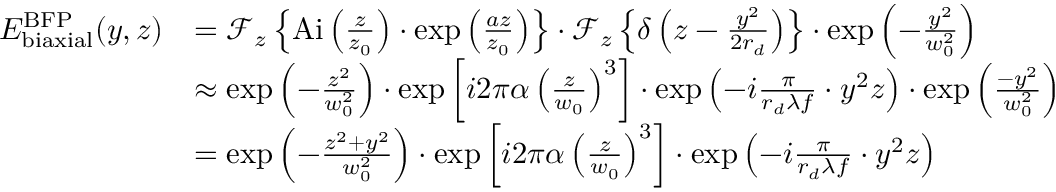Convert formula to latex. <formula><loc_0><loc_0><loc_500><loc_500>\begin{array} { r l } { E _ { b i a x i a l } ^ { B F P } ( y , z ) } & { = { \mathcal { F } } _ { z } \left \{ { A i } \left ( \frac { z } { z _ { 0 } } \right ) \cdot \exp \left ( \frac { a z } { z _ { 0 } } \right ) \right \} \cdot { \mathcal { F } } _ { z } \left \{ \delta \left ( z - \frac { y ^ { 2 } } { 2 r _ { d } } \right ) \right \} \cdot \exp \left ( - \frac { y ^ { 2 } } { w _ { 0 } ^ { 2 } } \right ) } \\ & { \approx \exp \left ( - \frac { z ^ { 2 } } { w _ { 0 } ^ { 2 } } \right ) \cdot \exp \left [ i 2 \pi \alpha \left ( \frac { z } { w _ { 0 } } \right ) ^ { 3 } \right ] \cdot \exp \left ( - i \frac { \pi } { r _ { d } \lambda f } \cdot y ^ { 2 } z \right ) \cdot \exp \left ( \frac { - y ^ { 2 } } { w _ { 0 } ^ { 2 } } \right ) } \\ & { = \exp \left ( - \frac { z ^ { 2 } + y ^ { 2 } } { w _ { 0 } ^ { 2 } } \right ) \cdot \exp \left [ i 2 \pi \alpha \left ( \frac { z } { w _ { 0 } } \right ) ^ { 3 } \right ] \cdot \exp \left ( - i \frac { \pi } { r _ { d } \lambda f } \cdot y ^ { 2 } z \right ) } \end{array}</formula> 